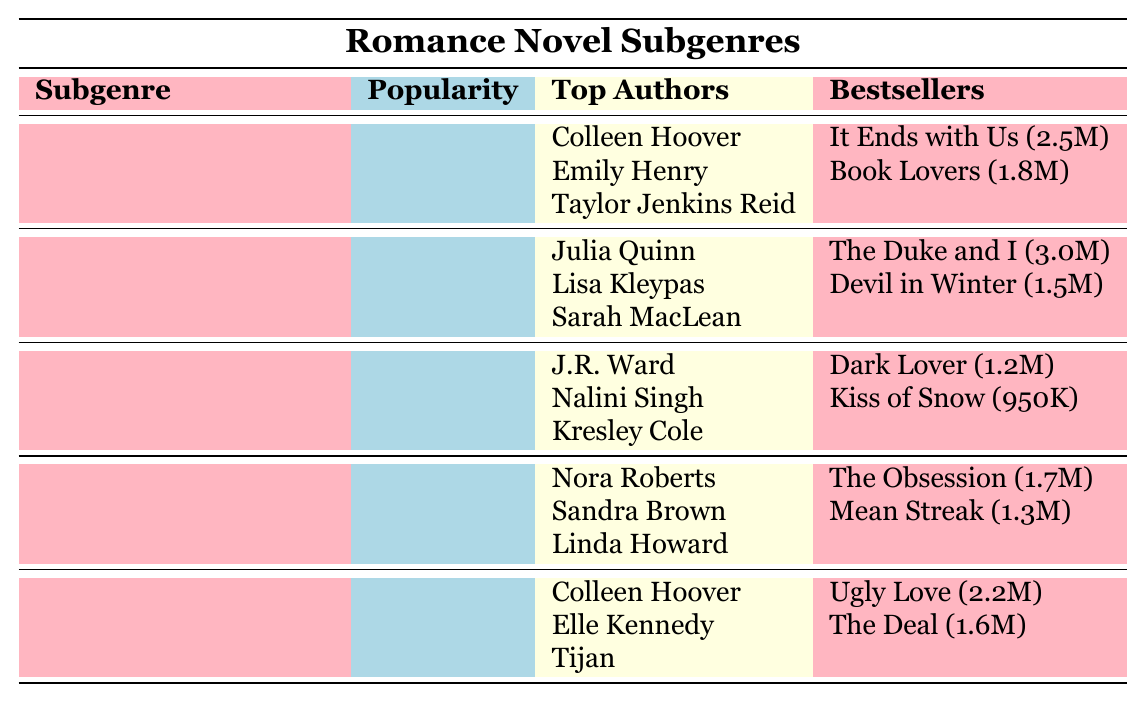What is the popularity rating of Contemporary Romance? The table lists the popularity rating for each subgenre. Looking at the row for Contemporary Romance, the popularity rating is stated as 9.2.
Answer: 9.2 Who is the author of the bestseller "The Duke and I"? Under the Historical Romance subgenre, "The Duke and I" is mentioned as a bestseller. The author listed next to that title is Julia Quinn.
Answer: Julia Quinn Which subgenre has the lowest popularity rating? By comparing the popularity ratings in the table, Paranormal Romance has the lowest rating at 7.9.
Answer: Paranormal Romance What is the total sales of the bestsellers listed for Romantic Suspense? Looking at the bestsellers under Romantic Suspense, the sales figures are: The Obsession (1.7 million) and Mean Streak (1.3 million). Adding these gives 1.7M + 1.3M = 3.0M.
Answer: 3.0 million Which two authors have bestselling titles in Contemporary Romance? The bestsellers listed under Contemporary Romance include "It Ends with Us" by Colleen Hoover and "Book Lovers" by Emily Henry. Thus, Colleen Hoover and Emily Henry are the two authors.
Answer: Colleen Hoover and Emily Henry Is "Kiss of Snow" a bestseller in Historical Romance? From the Historical Romance section, "Kiss of Snow" appears under the Paranormal Romance subgenre, which means it is not a bestseller in Historical Romance.
Answer: No What is the average popularity rating of all the subgenres listed? The popularity ratings are: 9.2 (Contemporary), 8.7 (Historical), 7.9 (Paranormal), 8.5 (Romantic Suspense), 8.9 (New Adult). Calculating the average: (9.2 + 8.7 + 7.9 + 8.5 + 8.9) / 5 = 8.84.
Answer: 8.84 Which bestseller has the highest sales and what is the title? The table lists bestseller sales across subgenres. "The Duke and I" has the highest sales at 3.0 million, making it the top seller.
Answer: The Duke and I Which subgenre features the most top authors? Each subgenre has three top authors listed, making it equal across all subgenres. Thus, none can be singled out as having more.
Answer: None Are any authors common between Contemporary Romance and New Adult Romance? Colleen Hoover appears in both Contemporary Romance and New Adult Romance as a top author, indicating that there is a common author.
Answer: Yes 